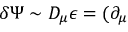<formula> <loc_0><loc_0><loc_500><loc_500>\delta \Psi \sim D _ { \mu } \epsilon = ( \partial _ { \mu }</formula> 